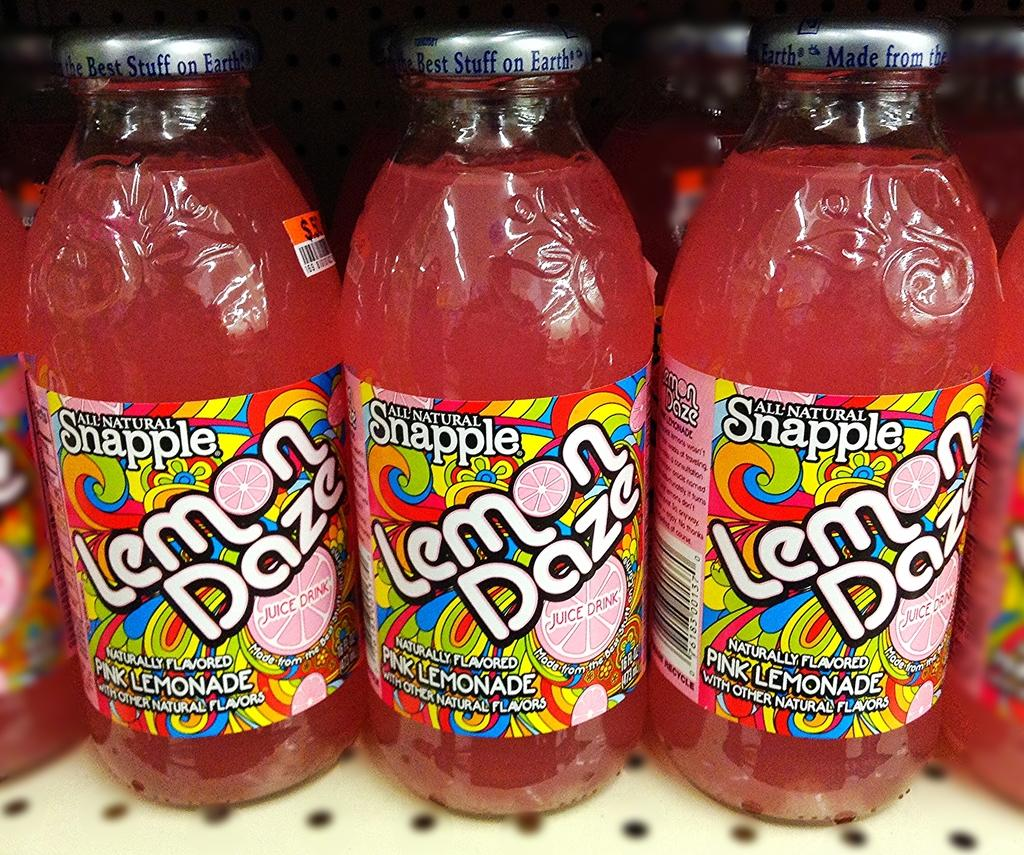<image>
Describe the image concisely. Bottles of Snapple Lemon Daze are on a shelf. 